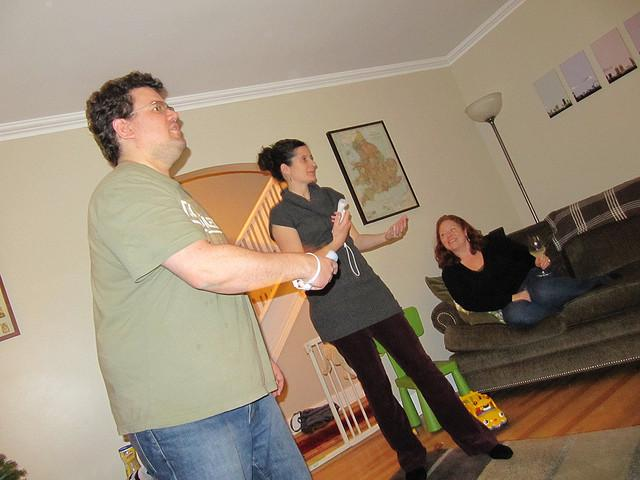What are the majority of the people doing? standing 